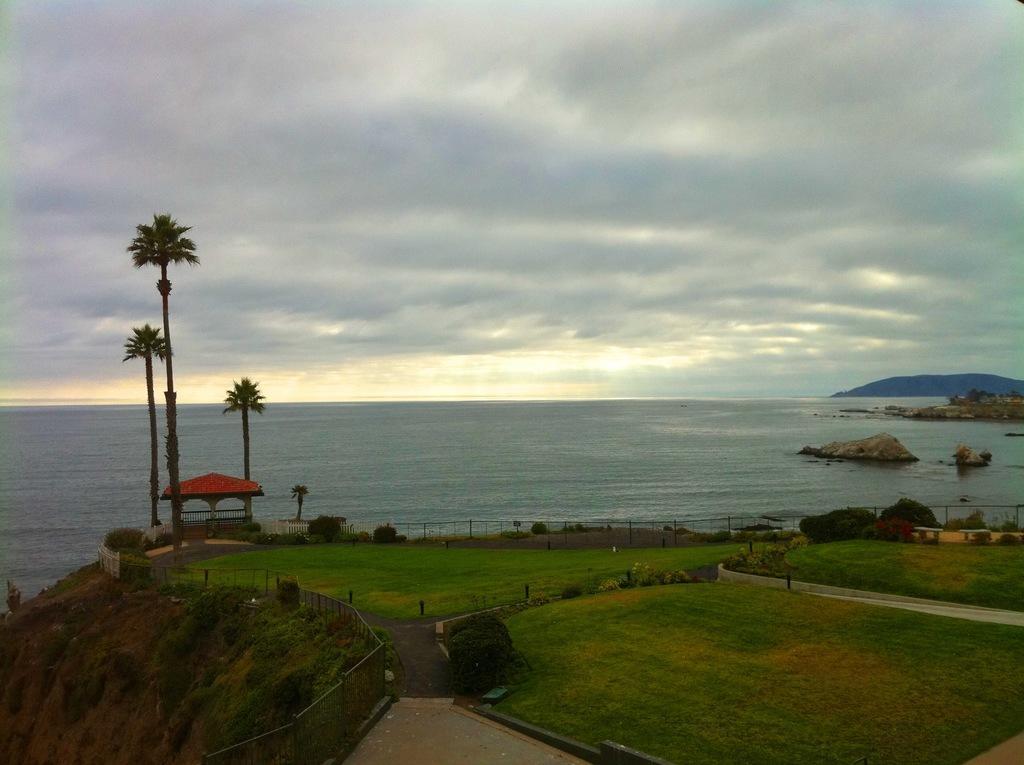In one or two sentences, can you explain what this image depicts? In the image we can see grass, plant, trees, mountain, water, fence, footpath, big stones, tent and a cloudy sky. 